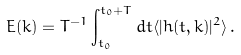Convert formula to latex. <formula><loc_0><loc_0><loc_500><loc_500>E ( k ) = T ^ { - 1 } \int _ { t _ { 0 } } ^ { t _ { 0 } + T } d t \langle | h ( t , k ) | ^ { 2 } \rangle \, .</formula> 